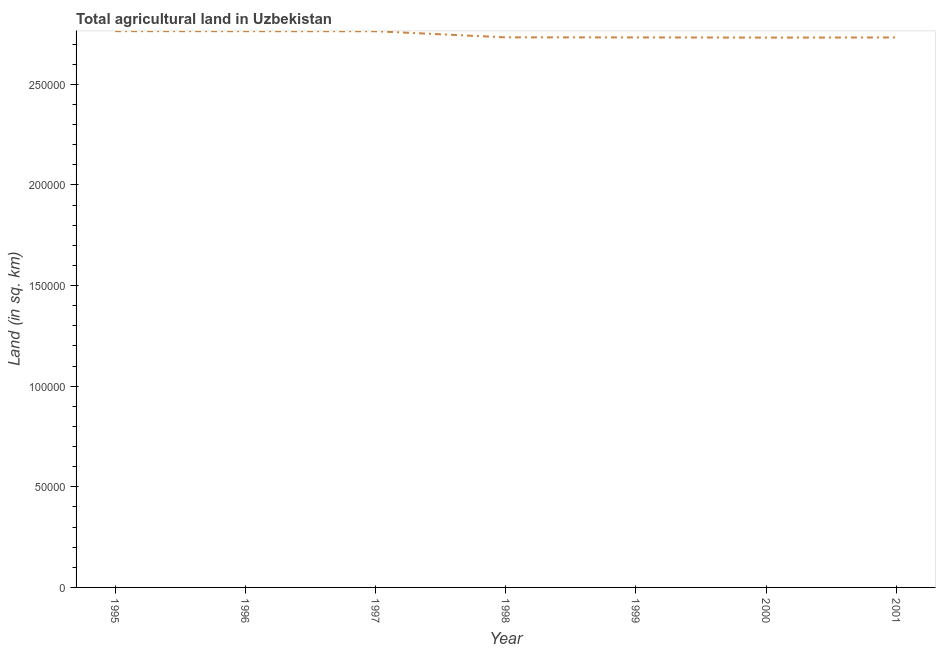What is the agricultural land in 1996?
Provide a short and direct response. 2.76e+05. Across all years, what is the maximum agricultural land?
Make the answer very short. 2.76e+05. Across all years, what is the minimum agricultural land?
Provide a succinct answer. 2.73e+05. In which year was the agricultural land maximum?
Your answer should be very brief. 1995. In which year was the agricultural land minimum?
Give a very brief answer. 2000. What is the sum of the agricultural land?
Offer a terse response. 1.92e+06. What is the difference between the agricultural land in 1997 and 2000?
Provide a succinct answer. 3150. What is the average agricultural land per year?
Provide a short and direct response. 2.75e+05. What is the median agricultural land?
Offer a very short reply. 2.73e+05. Do a majority of the years between 1995 and 1997 (inclusive) have agricultural land greater than 60000 sq. km?
Ensure brevity in your answer.  Yes. What is the ratio of the agricultural land in 1996 to that in 1998?
Ensure brevity in your answer.  1.01. Is the difference between the agricultural land in 1998 and 2000 greater than the difference between any two years?
Your answer should be very brief. No. What is the difference between the highest and the second highest agricultural land?
Offer a terse response. 20. What is the difference between the highest and the lowest agricultural land?
Your answer should be very brief. 3200. What is the difference between two consecutive major ticks on the Y-axis?
Your answer should be very brief. 5.00e+04. Are the values on the major ticks of Y-axis written in scientific E-notation?
Your answer should be very brief. No. Does the graph contain any zero values?
Keep it short and to the point. No. Does the graph contain grids?
Ensure brevity in your answer.  No. What is the title of the graph?
Keep it short and to the point. Total agricultural land in Uzbekistan. What is the label or title of the Y-axis?
Provide a succinct answer. Land (in sq. km). What is the Land (in sq. km) in 1995?
Your response must be concise. 2.76e+05. What is the Land (in sq. km) of 1996?
Offer a terse response. 2.76e+05. What is the Land (in sq. km) of 1997?
Your answer should be compact. 2.76e+05. What is the Land (in sq. km) of 1998?
Ensure brevity in your answer.  2.73e+05. What is the Land (in sq. km) of 1999?
Ensure brevity in your answer.  2.73e+05. What is the Land (in sq. km) of 2000?
Offer a very short reply. 2.73e+05. What is the Land (in sq. km) of 2001?
Ensure brevity in your answer.  2.73e+05. What is the difference between the Land (in sq. km) in 1995 and 1996?
Ensure brevity in your answer.  20. What is the difference between the Land (in sq. km) in 1995 and 1998?
Your answer should be very brief. 3080. What is the difference between the Land (in sq. km) in 1995 and 1999?
Your response must be concise. 3120. What is the difference between the Land (in sq. km) in 1995 and 2000?
Keep it short and to the point. 3200. What is the difference between the Land (in sq. km) in 1995 and 2001?
Offer a terse response. 3150. What is the difference between the Land (in sq. km) in 1996 and 1998?
Offer a very short reply. 3060. What is the difference between the Land (in sq. km) in 1996 and 1999?
Make the answer very short. 3100. What is the difference between the Land (in sq. km) in 1996 and 2000?
Keep it short and to the point. 3180. What is the difference between the Land (in sq. km) in 1996 and 2001?
Your response must be concise. 3130. What is the difference between the Land (in sq. km) in 1997 and 1998?
Provide a succinct answer. 3030. What is the difference between the Land (in sq. km) in 1997 and 1999?
Your answer should be very brief. 3070. What is the difference between the Land (in sq. km) in 1997 and 2000?
Ensure brevity in your answer.  3150. What is the difference between the Land (in sq. km) in 1997 and 2001?
Give a very brief answer. 3100. What is the difference between the Land (in sq. km) in 1998 and 2000?
Keep it short and to the point. 120. What is the difference between the Land (in sq. km) in 1999 and 2001?
Your answer should be very brief. 30. What is the ratio of the Land (in sq. km) in 1995 to that in 1997?
Offer a terse response. 1. What is the ratio of the Land (in sq. km) in 1995 to that in 1999?
Your response must be concise. 1.01. What is the ratio of the Land (in sq. km) in 1995 to that in 2000?
Provide a short and direct response. 1.01. What is the ratio of the Land (in sq. km) in 1996 to that in 2001?
Offer a terse response. 1.01. What is the ratio of the Land (in sq. km) in 1997 to that in 2000?
Make the answer very short. 1.01. What is the ratio of the Land (in sq. km) in 1998 to that in 1999?
Your answer should be compact. 1. What is the ratio of the Land (in sq. km) in 1998 to that in 2000?
Offer a very short reply. 1. What is the ratio of the Land (in sq. km) in 1998 to that in 2001?
Offer a terse response. 1. What is the ratio of the Land (in sq. km) in 1999 to that in 2001?
Your answer should be compact. 1. What is the ratio of the Land (in sq. km) in 2000 to that in 2001?
Offer a very short reply. 1. 